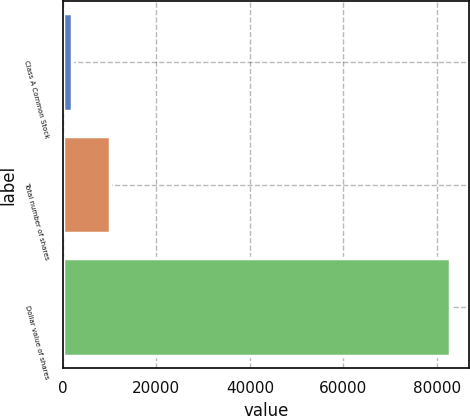Convert chart to OTSL. <chart><loc_0><loc_0><loc_500><loc_500><bar_chart><fcel>Class A Common Stock<fcel>Total number of shares<fcel>Dollar value of shares<nl><fcel>2008<fcel>10080.5<fcel>82733<nl></chart> 